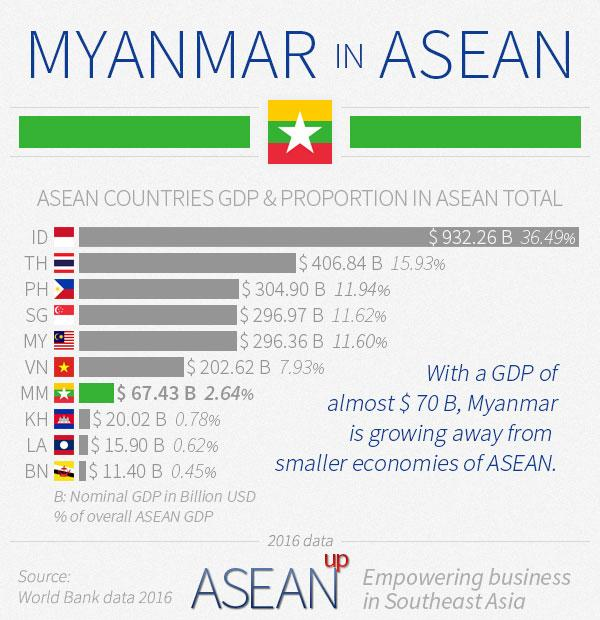Highlight a few significant elements in this photo. The countries that contribute more than 10% and less than 15% to the total Gross Domestic Product (GDP) of the Association of Southeast Asian Nations (ASEAN) are the Philippines, Singapore, and Malaysia. The bar chart representing the country of Myanmar, also known as Burma, is green. A small percentage of countries, including KH, LA, and BN, contribute less than 1% of their GDP to the global economy. 